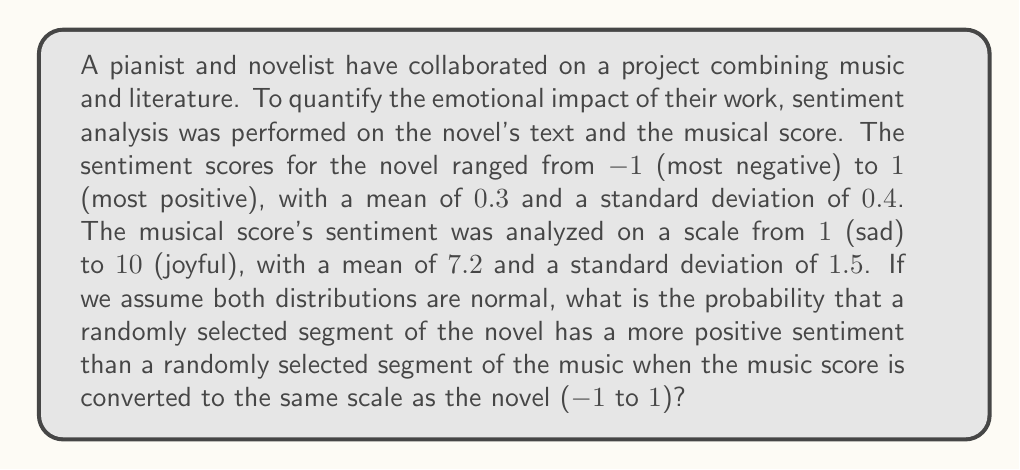Teach me how to tackle this problem. To solve this problem, we need to follow these steps:

1. Convert the music score scale to match the novel's scale (-1 to 1).
2. Calculate the z-score for the point where the two distributions intersect.
3. Use the standard normal distribution to find the probability.

Step 1: Convert music score scale
Let's convert the music score mean and standard deviation to the -1 to 1 scale:

New mean: $\mu_m = \frac{2(7.2 - 1)}{10 - 1} - 1 = 0.3777778$
New standard deviation: $\sigma_m = \frac{2 \cdot 1.5}{10 - 1} = 0.3333333$

Step 2: Calculate the z-score
We need to find the point where the two normal distributions intersect. This occurs when:

$$\frac{x - \mu_n}{\sigma_n} = \frac{x - \mu_m}{\sigma_m}$$

Where:
$\mu_n = 0.3$ (novel mean)
$\sigma_n = 0.4$ (novel standard deviation)
$\mu_m = 0.3777778$ (converted music mean)
$\sigma_m = 0.3333333$ (converted music standard deviation)

Solving for x:

$$\frac{x - 0.3}{0.4} = \frac{x - 0.3777778}{0.3333333}$$

$$3x - 0.9 = 3.6x - 1.3600001$$
$$0.4600001 = 0.6x$$
$$x = 0.7666668$$

Now we calculate the z-score for this x-value relative to the novel's distribution:

$$z = \frac{x - \mu_n}{\sigma_n} = \frac{0.7666668 - 0.3}{0.4} = 1.1666668$$

Step 3: Find the probability
The probability that the novel's sentiment is more positive than the music's sentiment is the area to the right of this z-score in the standard normal distribution.

Using a standard normal table or calculator, we find:

$$P(Z > 1.1666668) = 1 - P(Z < 1.1666668) = 1 - 0.8783 = 0.1217$$

Therefore, the probability is approximately 0.1217 or 12.17%.
Answer: 0.1217 